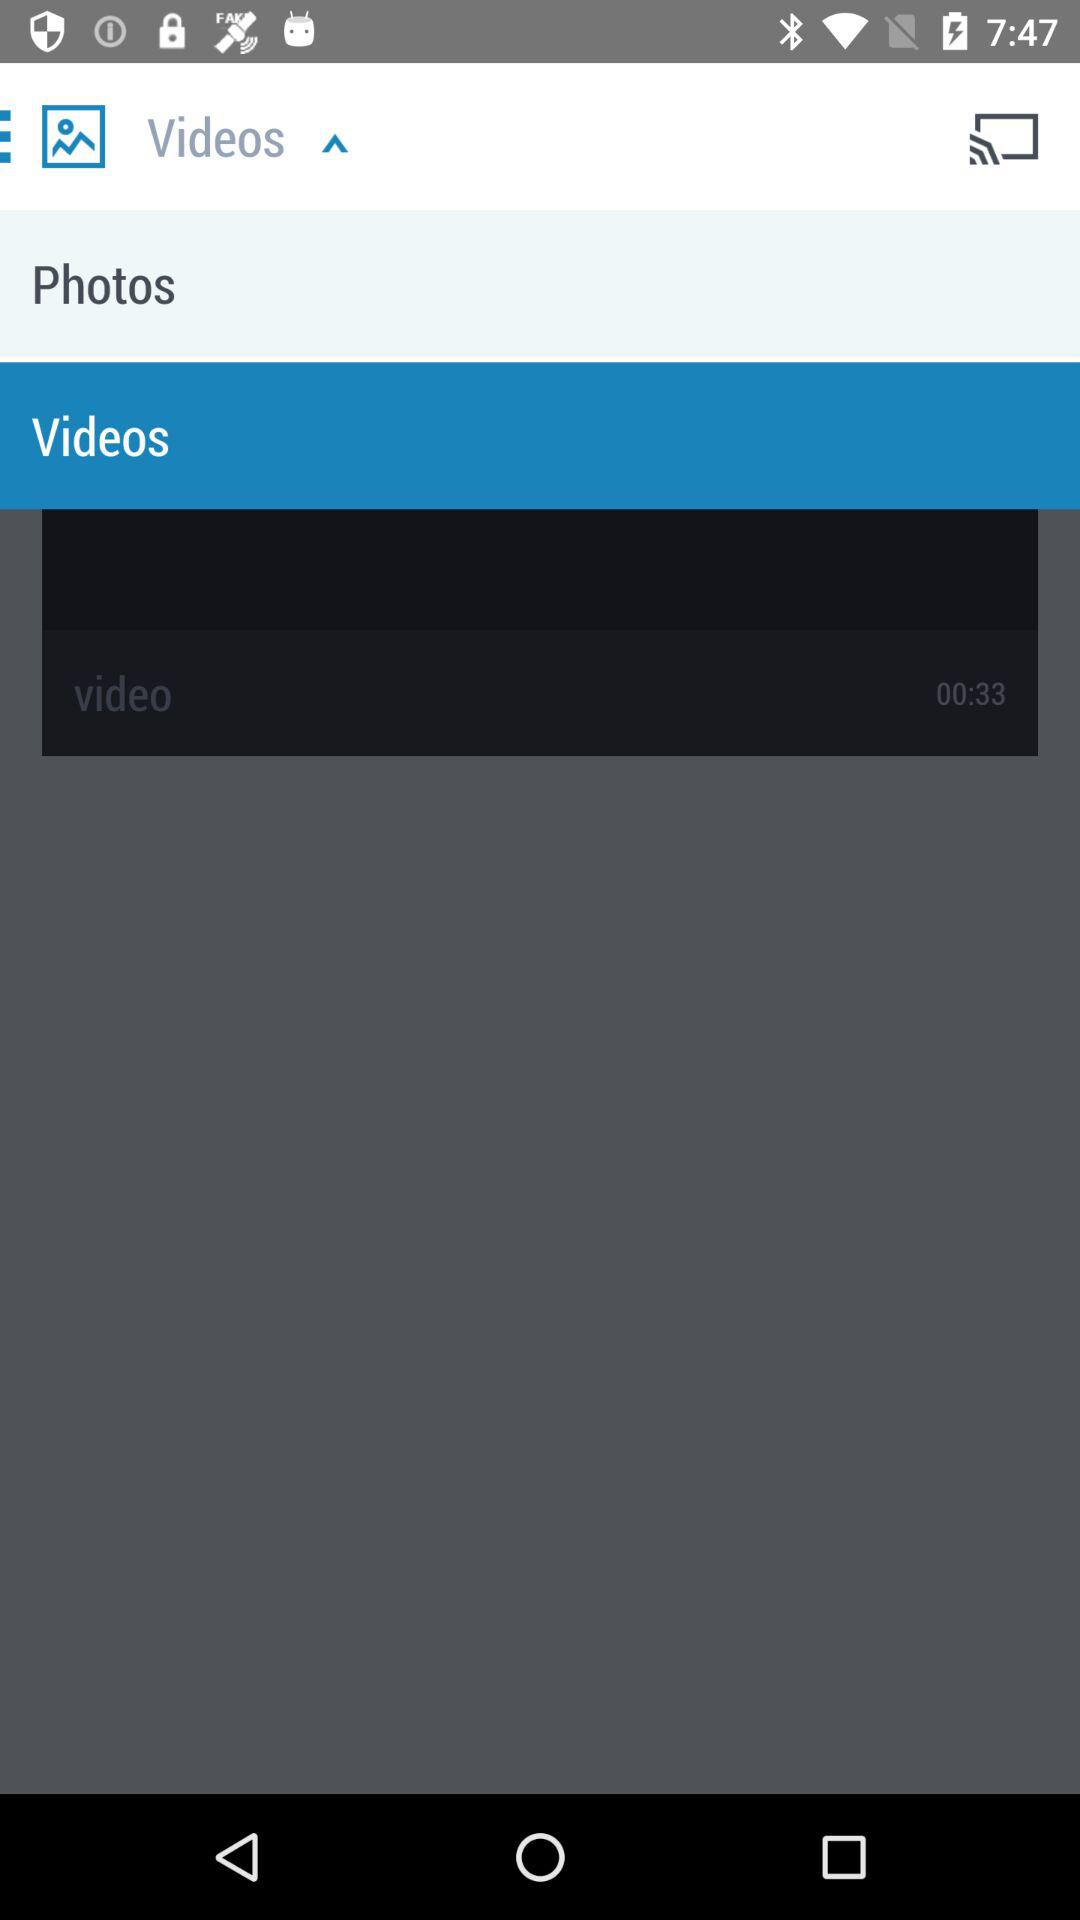How many more videos are there than photos?
Answer the question using a single word or phrase. 1 